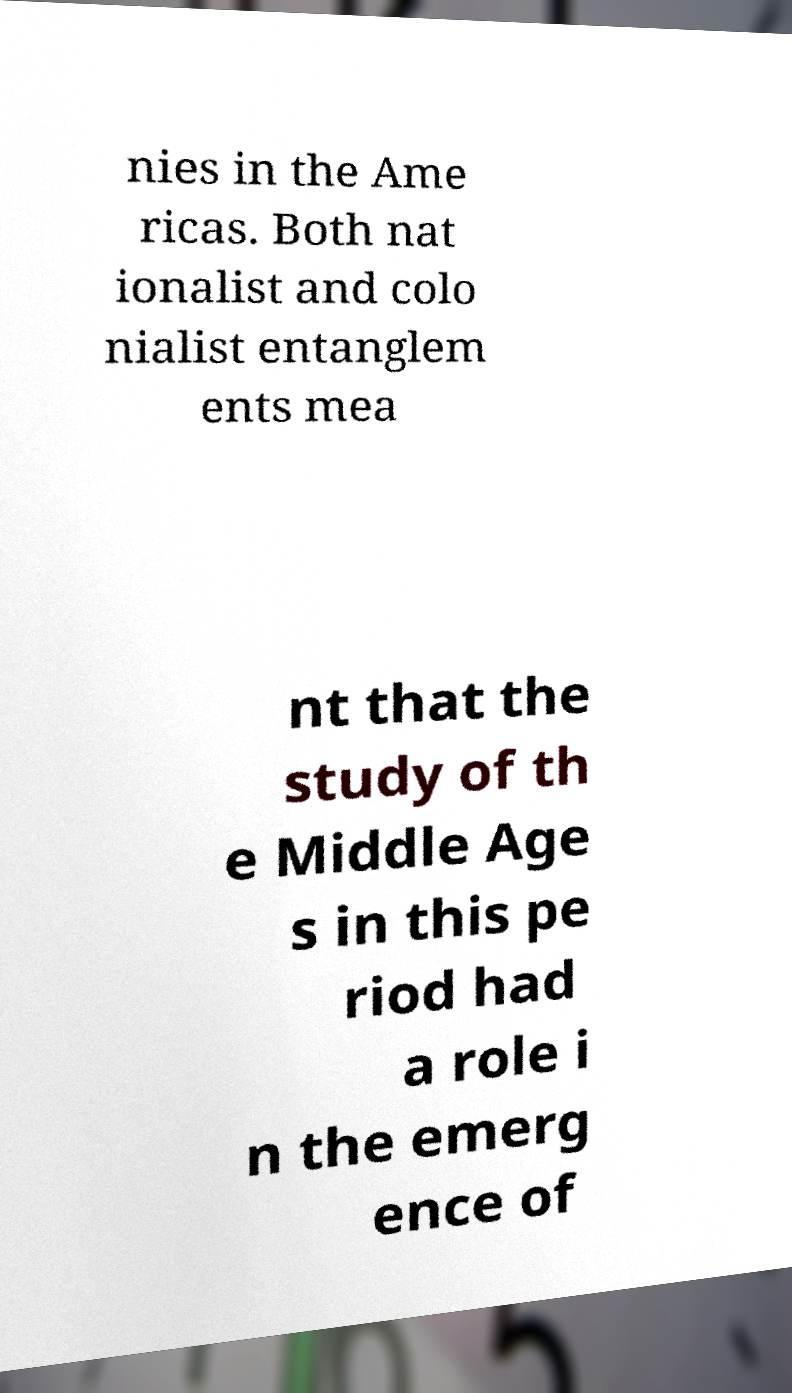Please read and relay the text visible in this image. What does it say? nies in the Ame ricas. Both nat ionalist and colo nialist entanglem ents mea nt that the study of th e Middle Age s in this pe riod had a role i n the emerg ence of 